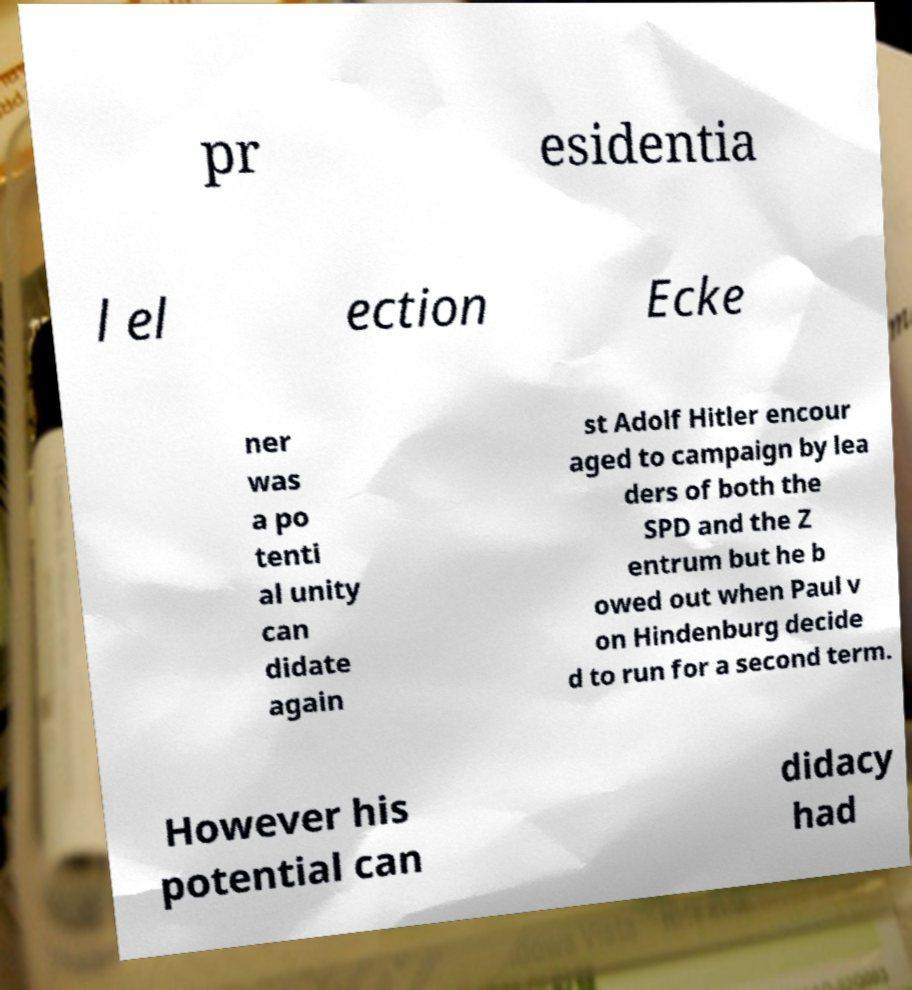Please read and relay the text visible in this image. What does it say? pr esidentia l el ection Ecke ner was a po tenti al unity can didate again st Adolf Hitler encour aged to campaign by lea ders of both the SPD and the Z entrum but he b owed out when Paul v on Hindenburg decide d to run for a second term. However his potential can didacy had 